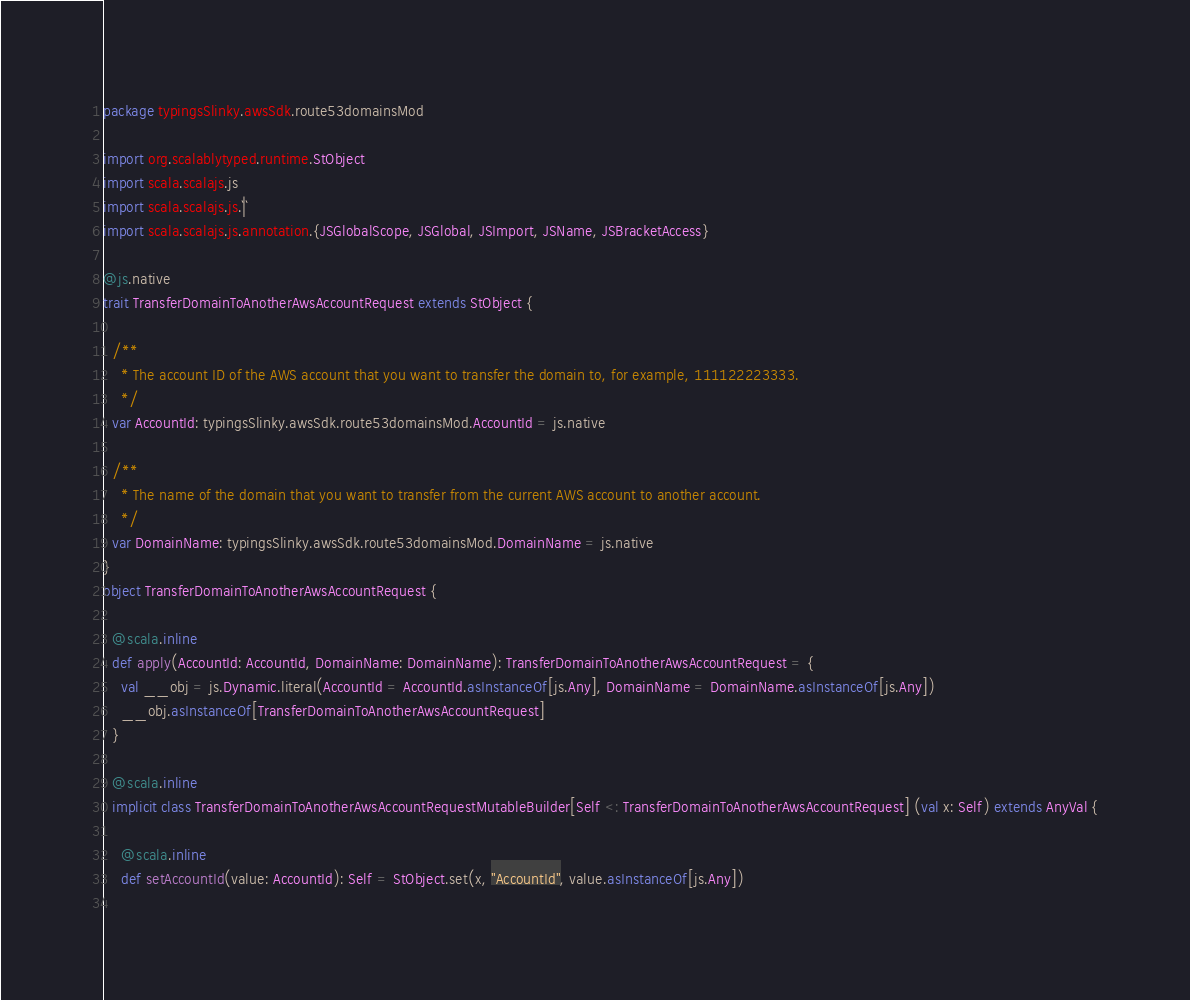<code> <loc_0><loc_0><loc_500><loc_500><_Scala_>package typingsSlinky.awsSdk.route53domainsMod

import org.scalablytyped.runtime.StObject
import scala.scalajs.js
import scala.scalajs.js.`|`
import scala.scalajs.js.annotation.{JSGlobalScope, JSGlobal, JSImport, JSName, JSBracketAccess}

@js.native
trait TransferDomainToAnotherAwsAccountRequest extends StObject {
  
  /**
    * The account ID of the AWS account that you want to transfer the domain to, for example, 111122223333.
    */
  var AccountId: typingsSlinky.awsSdk.route53domainsMod.AccountId = js.native
  
  /**
    * The name of the domain that you want to transfer from the current AWS account to another account.
    */
  var DomainName: typingsSlinky.awsSdk.route53domainsMod.DomainName = js.native
}
object TransferDomainToAnotherAwsAccountRequest {
  
  @scala.inline
  def apply(AccountId: AccountId, DomainName: DomainName): TransferDomainToAnotherAwsAccountRequest = {
    val __obj = js.Dynamic.literal(AccountId = AccountId.asInstanceOf[js.Any], DomainName = DomainName.asInstanceOf[js.Any])
    __obj.asInstanceOf[TransferDomainToAnotherAwsAccountRequest]
  }
  
  @scala.inline
  implicit class TransferDomainToAnotherAwsAccountRequestMutableBuilder[Self <: TransferDomainToAnotherAwsAccountRequest] (val x: Self) extends AnyVal {
    
    @scala.inline
    def setAccountId(value: AccountId): Self = StObject.set(x, "AccountId", value.asInstanceOf[js.Any])
    </code> 